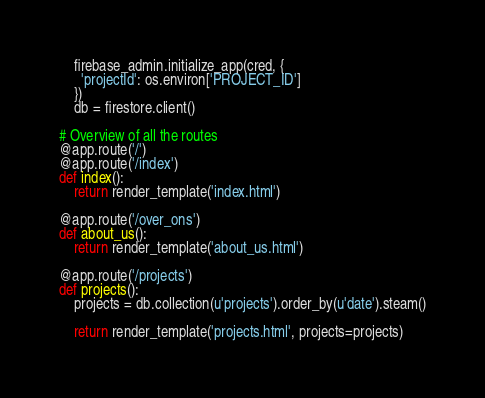Convert code to text. <code><loc_0><loc_0><loc_500><loc_500><_Python_>    firebase_admin.initialize_app(cred, {
      'projectId': os.environ['PROJECT_ID']
    })
    db = firestore.client()

# Overview of all the routes
@app.route('/')
@app.route('/index')
def index():
    return render_template('index.html')

@app.route('/over_ons')
def about_us():
    return render_template('about_us.html')

@app.route('/projects')
def projects():
    projects = db.collection(u'projects').order_by(u'date').steam()

    return render_template('projects.html', projects=projects)
</code> 